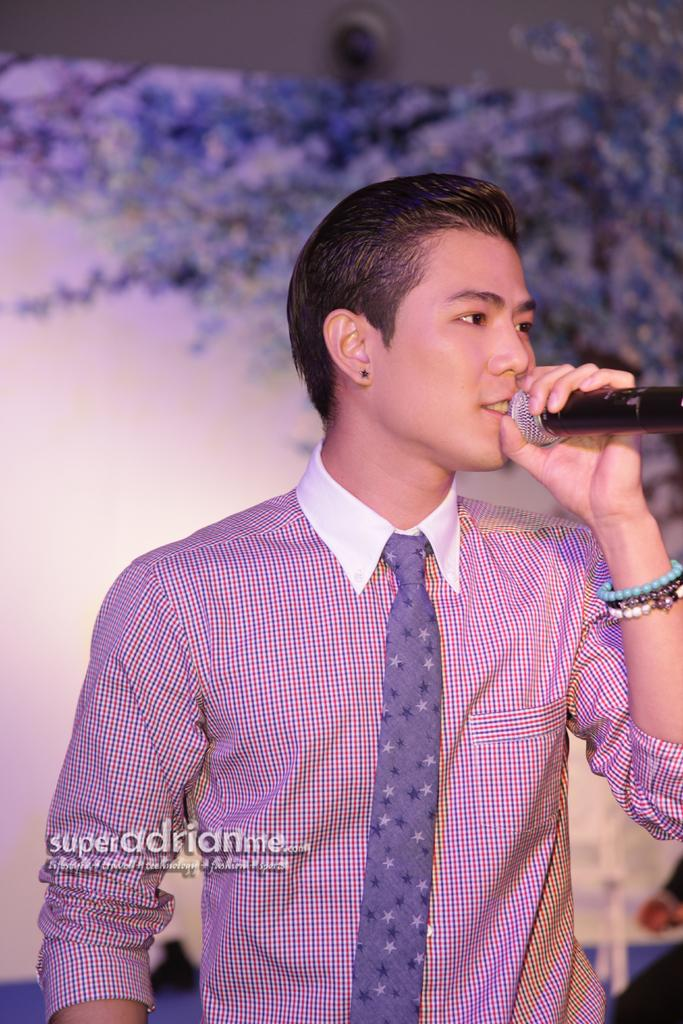Who is the main subject in the image? There is a man in the image. What is the man wearing? The man is wearing a shirt and tie. What is the man doing in the image? The man is singing. What object is the man holding in his hand? The man is holding a microphone in his hand. What type of sponge can be seen on the ground in the image? There is no sponge present on the ground in the image. How many pails are visible in the image? There are no pails visible in the image. 